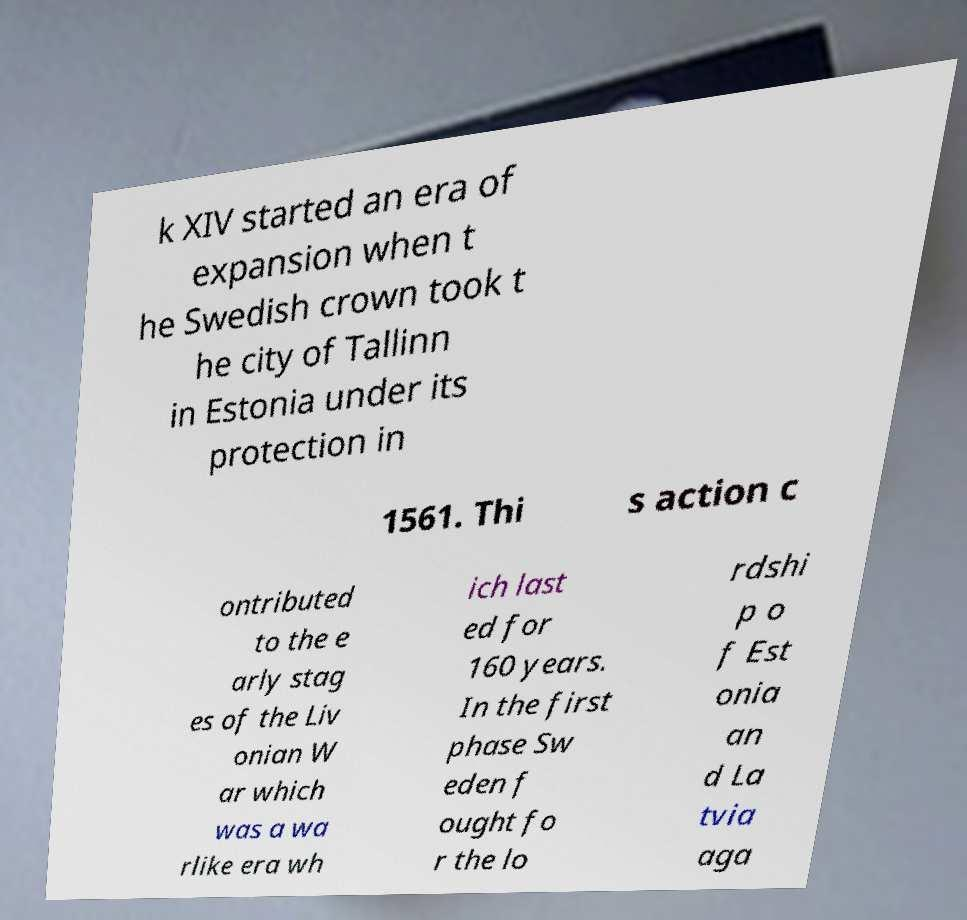What messages or text are displayed in this image? I need them in a readable, typed format. k XIV started an era of expansion when t he Swedish crown took t he city of Tallinn in Estonia under its protection in 1561. Thi s action c ontributed to the e arly stag es of the Liv onian W ar which was a wa rlike era wh ich last ed for 160 years. In the first phase Sw eden f ought fo r the lo rdshi p o f Est onia an d La tvia aga 